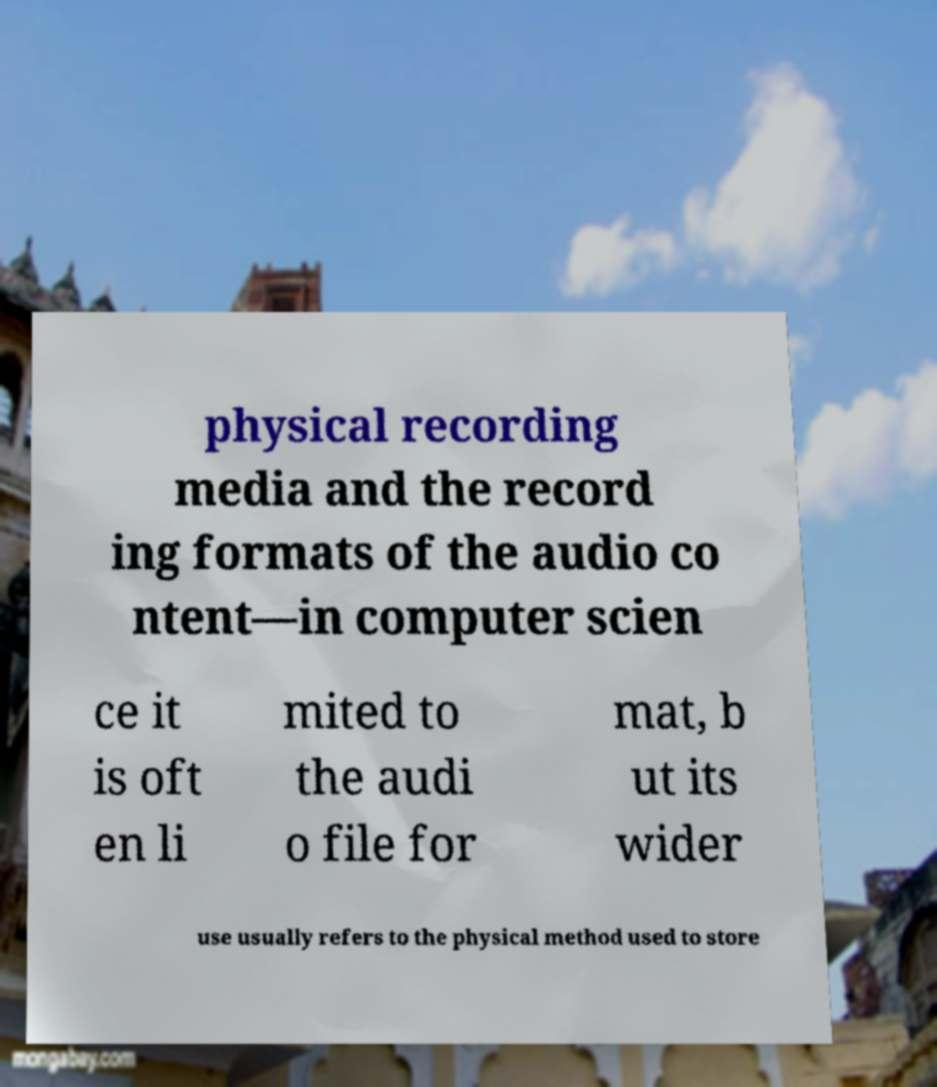Please identify and transcribe the text found in this image. physical recording media and the record ing formats of the audio co ntent—in computer scien ce it is oft en li mited to the audi o file for mat, b ut its wider use usually refers to the physical method used to store 